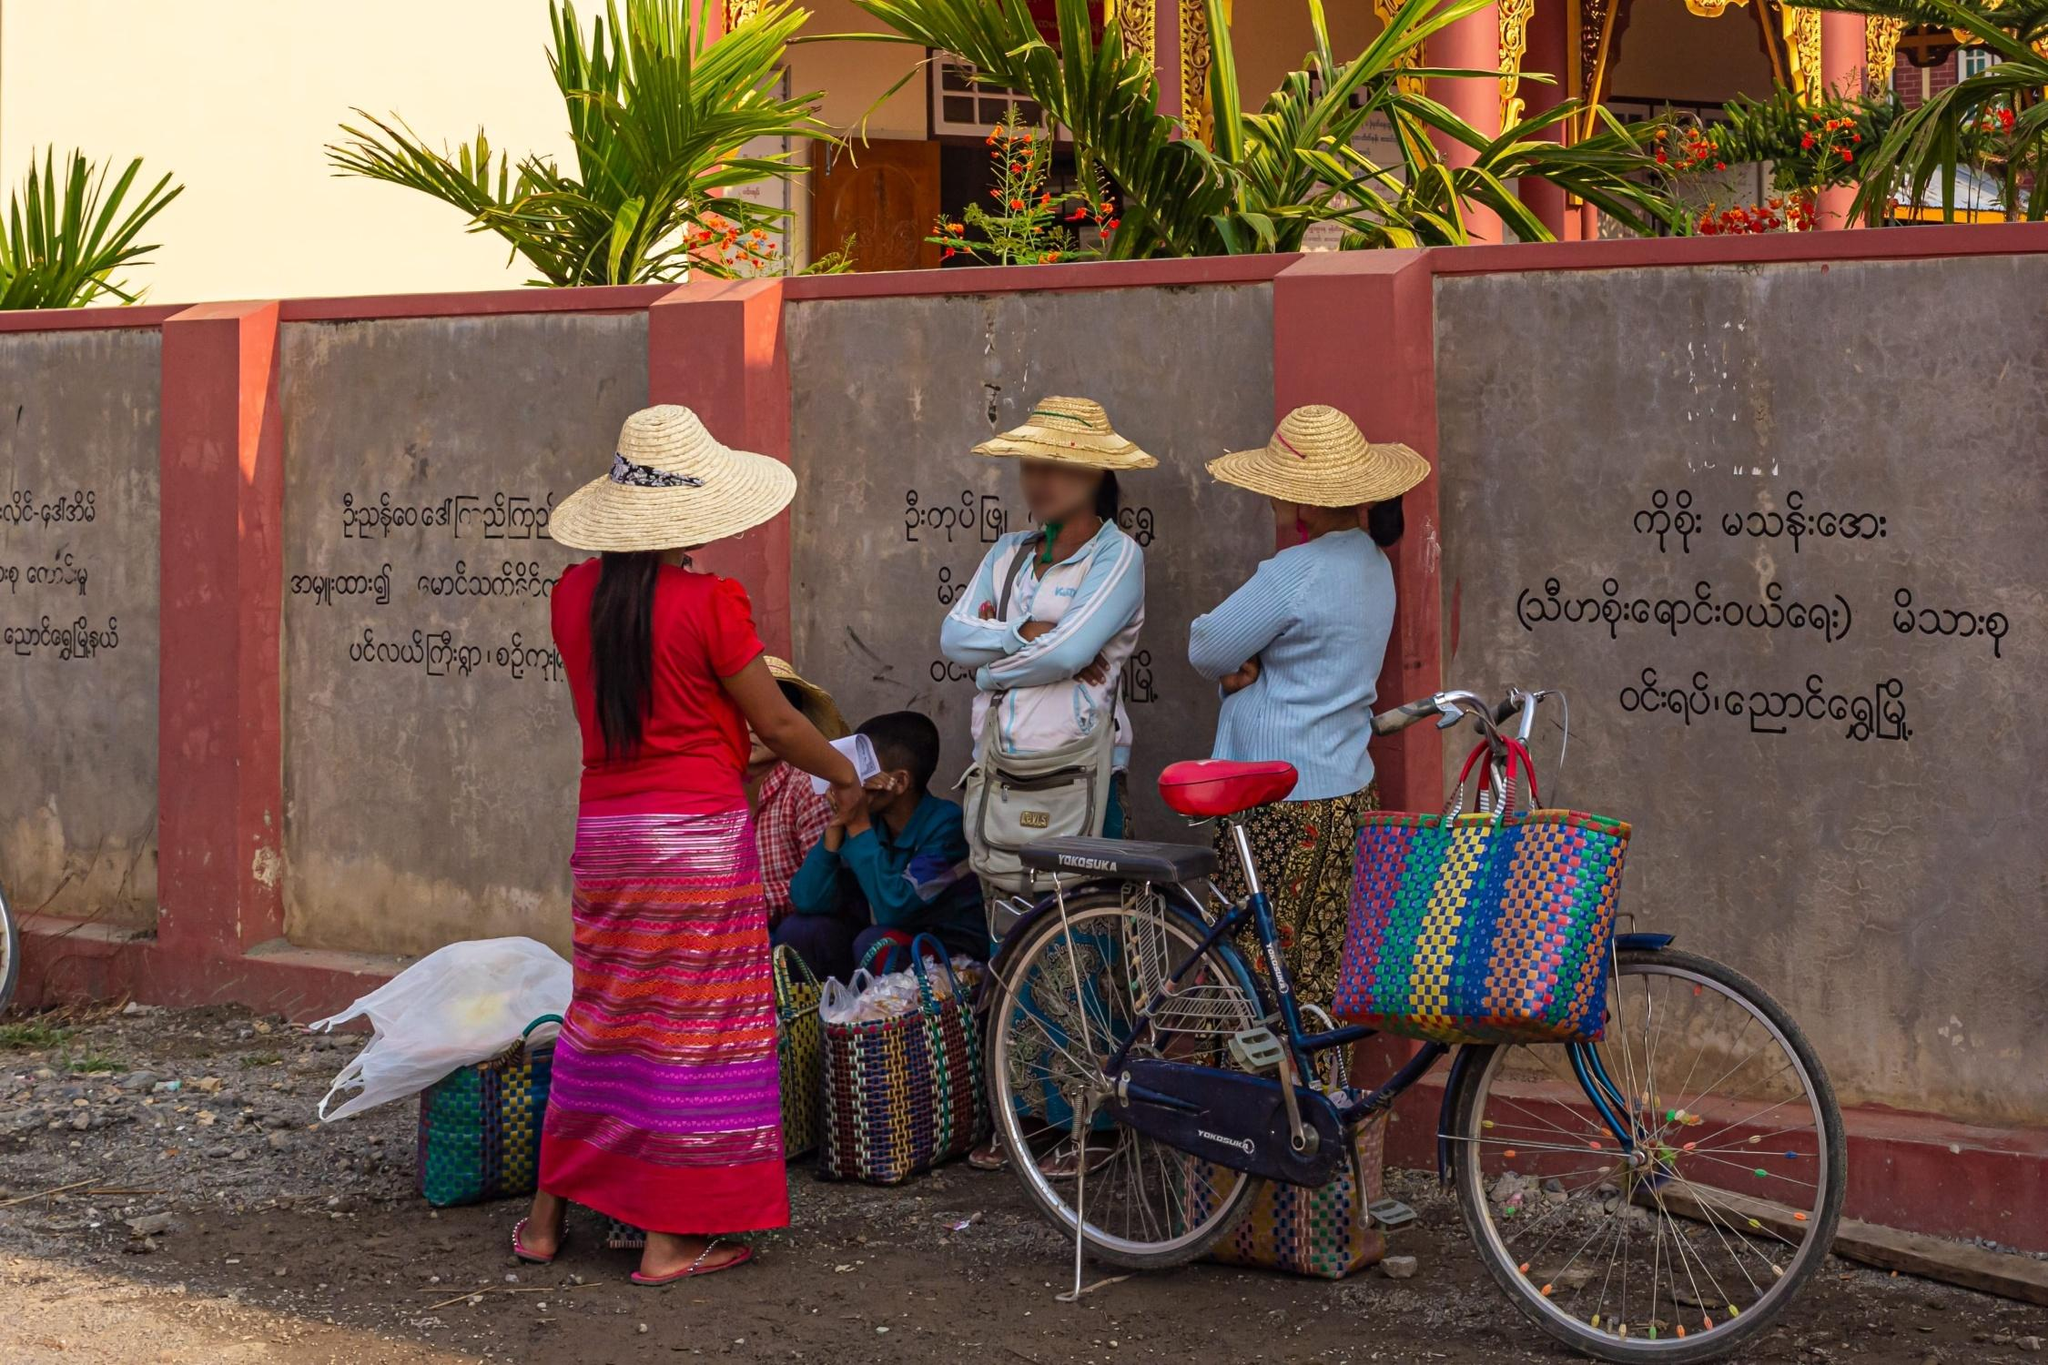Explain the visual content of the image in great detail.
 The image captures a lively scene of a group of people, dressed in traditional attire, gathered around a bicycle. The bicycle, adorned with baskets, serves as the focal point of the image. The individuals are seen wearing vibrant, colorful clothing, adding a sense of cultural richness to the scene. They are positioned in front of a light brown wall, which bears text written in a foreign language, adding an element of intrigue. The perspective of the image is from the side, providing a clear view of the people, the bicycle, and the intriguing wall in the background. The image seems to be a snapshot of a moment in everyday life, yet it also carries the weight of cultural significance. The identifier "sa_10284" doesn't provide any additional information about the landmark in the image. 